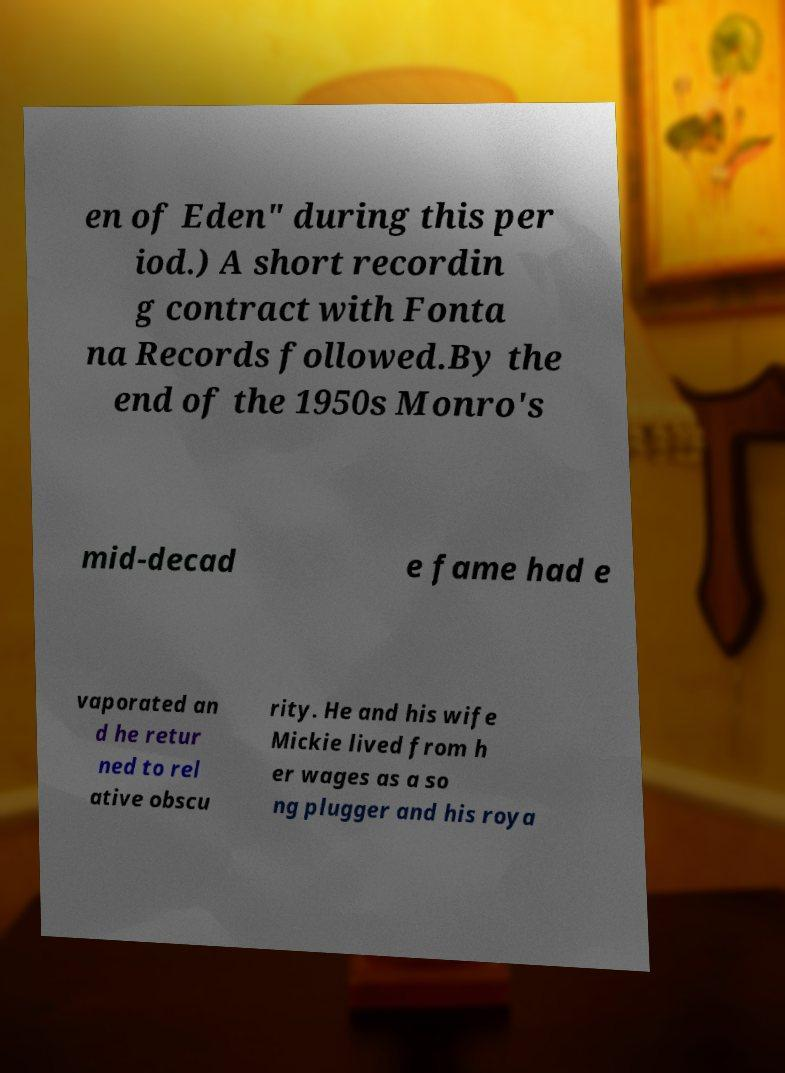Can you accurately transcribe the text from the provided image for me? en of Eden" during this per iod.) A short recordin g contract with Fonta na Records followed.By the end of the 1950s Monro's mid-decad e fame had e vaporated an d he retur ned to rel ative obscu rity. He and his wife Mickie lived from h er wages as a so ng plugger and his roya 